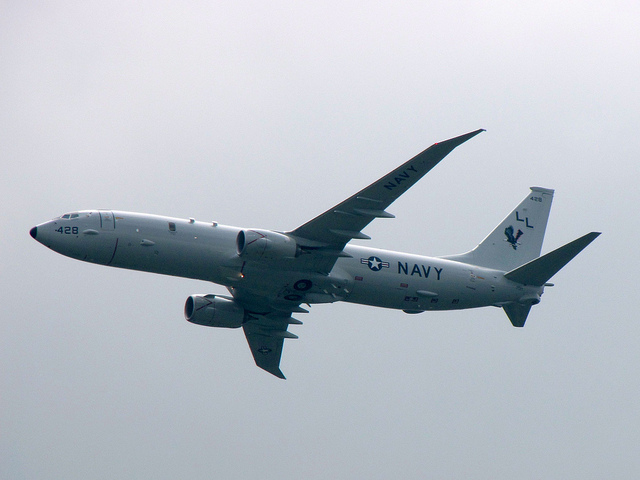Please transcribe the text information in this image. 428 NAVY 